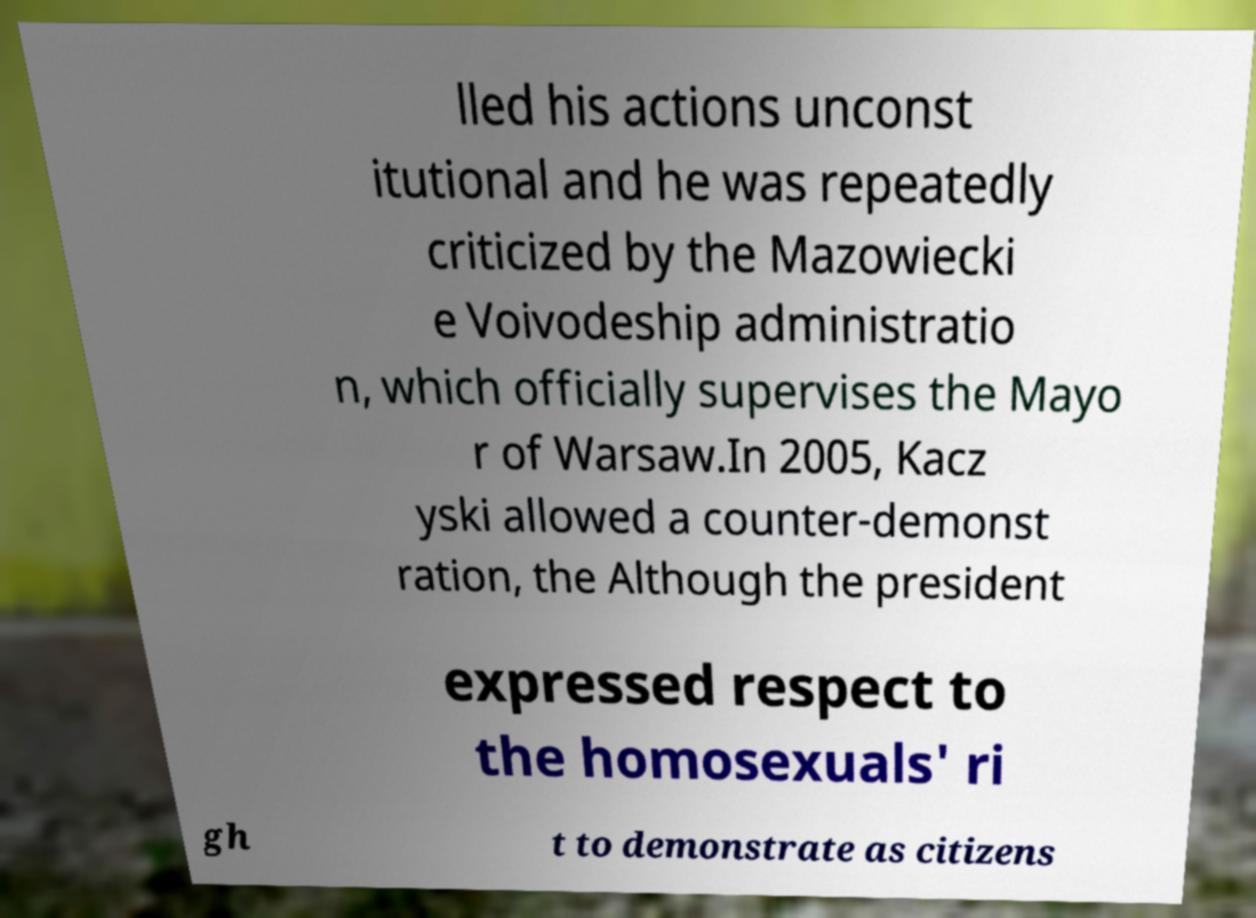Could you extract and type out the text from this image? lled his actions unconst itutional and he was repeatedly criticized by the Mazowiecki e Voivodeship administratio n, which officially supervises the Mayo r of Warsaw.In 2005, Kacz yski allowed a counter-demonst ration, the Although the president expressed respect to the homosexuals' ri gh t to demonstrate as citizens 